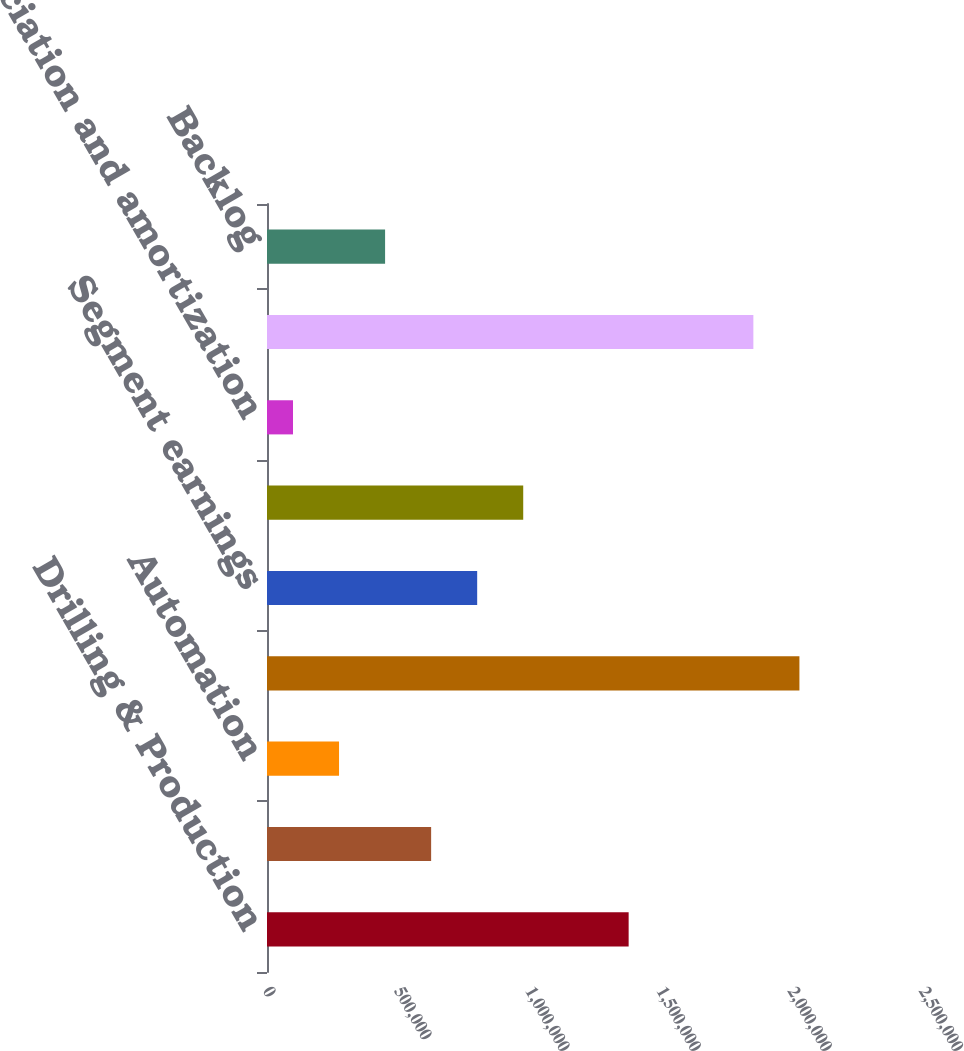Convert chart. <chart><loc_0><loc_0><loc_500><loc_500><bar_chart><fcel>Drilling & Production<fcel>Bearings & Compression<fcel>Automation<fcel>Total<fcel>Segment earnings<fcel>Segment EBITDA<fcel>Depreciation and amortization<fcel>Bookings<fcel>Backlog<nl><fcel>1.37822e+06<fcel>625508<fcel>274553<fcel>2.02904e+06<fcel>800986<fcel>976464<fcel>99075<fcel>1.85356e+06<fcel>450031<nl></chart> 